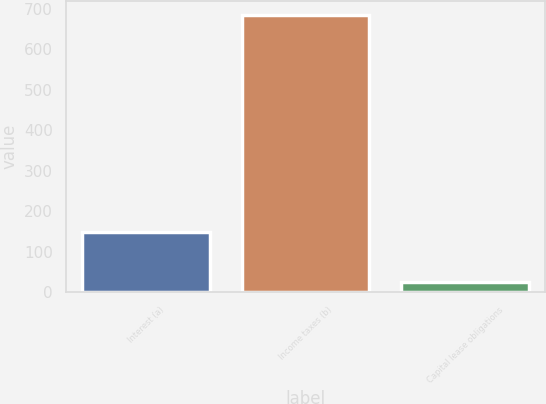Convert chart to OTSL. <chart><loc_0><loc_0><loc_500><loc_500><bar_chart><fcel>Interest (a)<fcel>Income taxes (b)<fcel>Capital lease obligations<nl><fcel>149<fcel>684<fcel>24<nl></chart> 